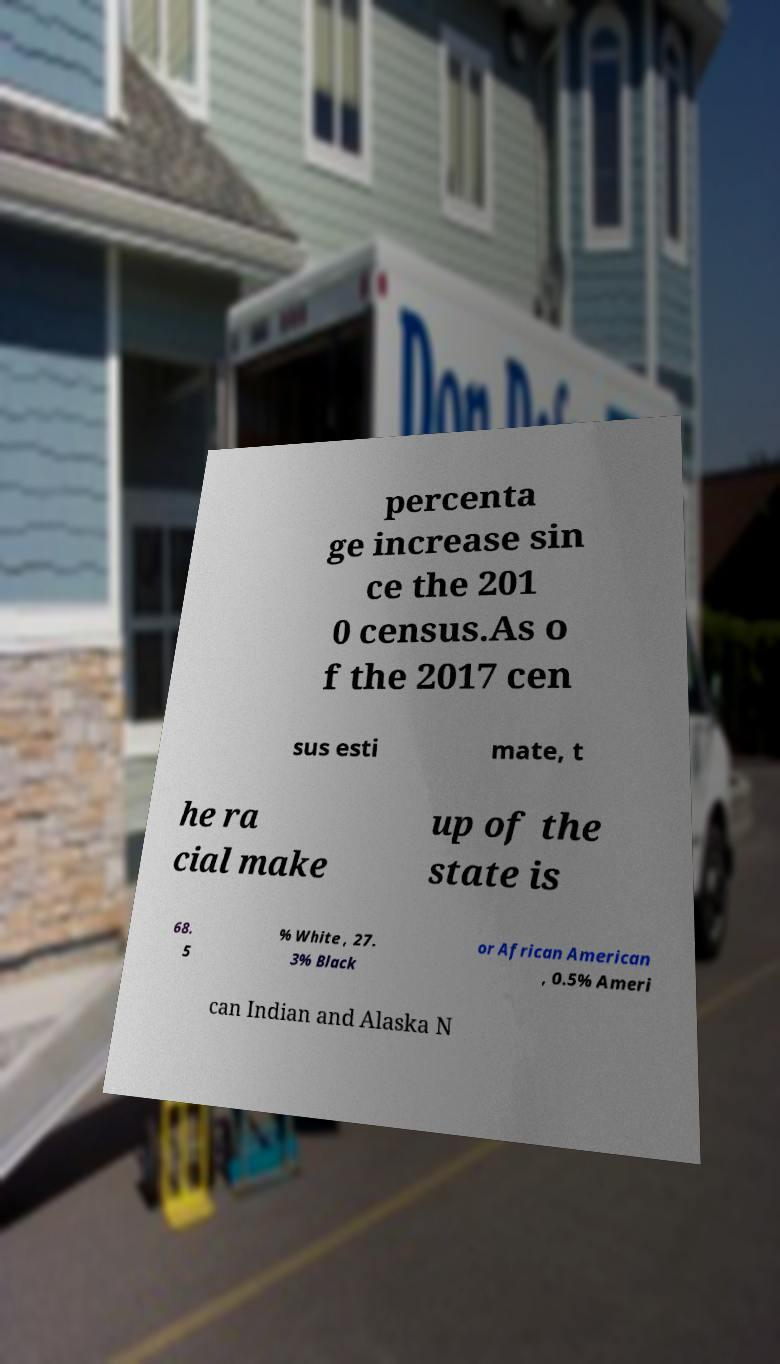What messages or text are displayed in this image? I need them in a readable, typed format. percenta ge increase sin ce the 201 0 census.As o f the 2017 cen sus esti mate, t he ra cial make up of the state is 68. 5 % White , 27. 3% Black or African American , 0.5% Ameri can Indian and Alaska N 